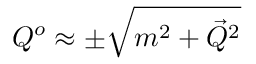Convert formula to latex. <formula><loc_0><loc_0><loc_500><loc_500>Q ^ { o } \approx \pm \sqrt { m ^ { 2 } + { \vec { Q } } ^ { 2 } }</formula> 